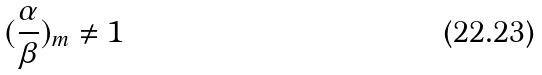Convert formula to latex. <formula><loc_0><loc_0><loc_500><loc_500>( \frac { \alpha } { \beta } ) _ { m } \ne 1</formula> 